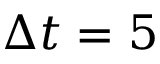Convert formula to latex. <formula><loc_0><loc_0><loc_500><loc_500>\Delta t = 5</formula> 